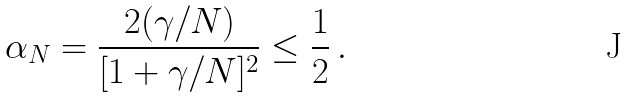<formula> <loc_0><loc_0><loc_500><loc_500>\alpha _ { N } = \frac { 2 ( \gamma / N ) } { [ 1 + \gamma / N ] ^ { 2 } } \leq \frac { 1 } { 2 } \, .</formula> 